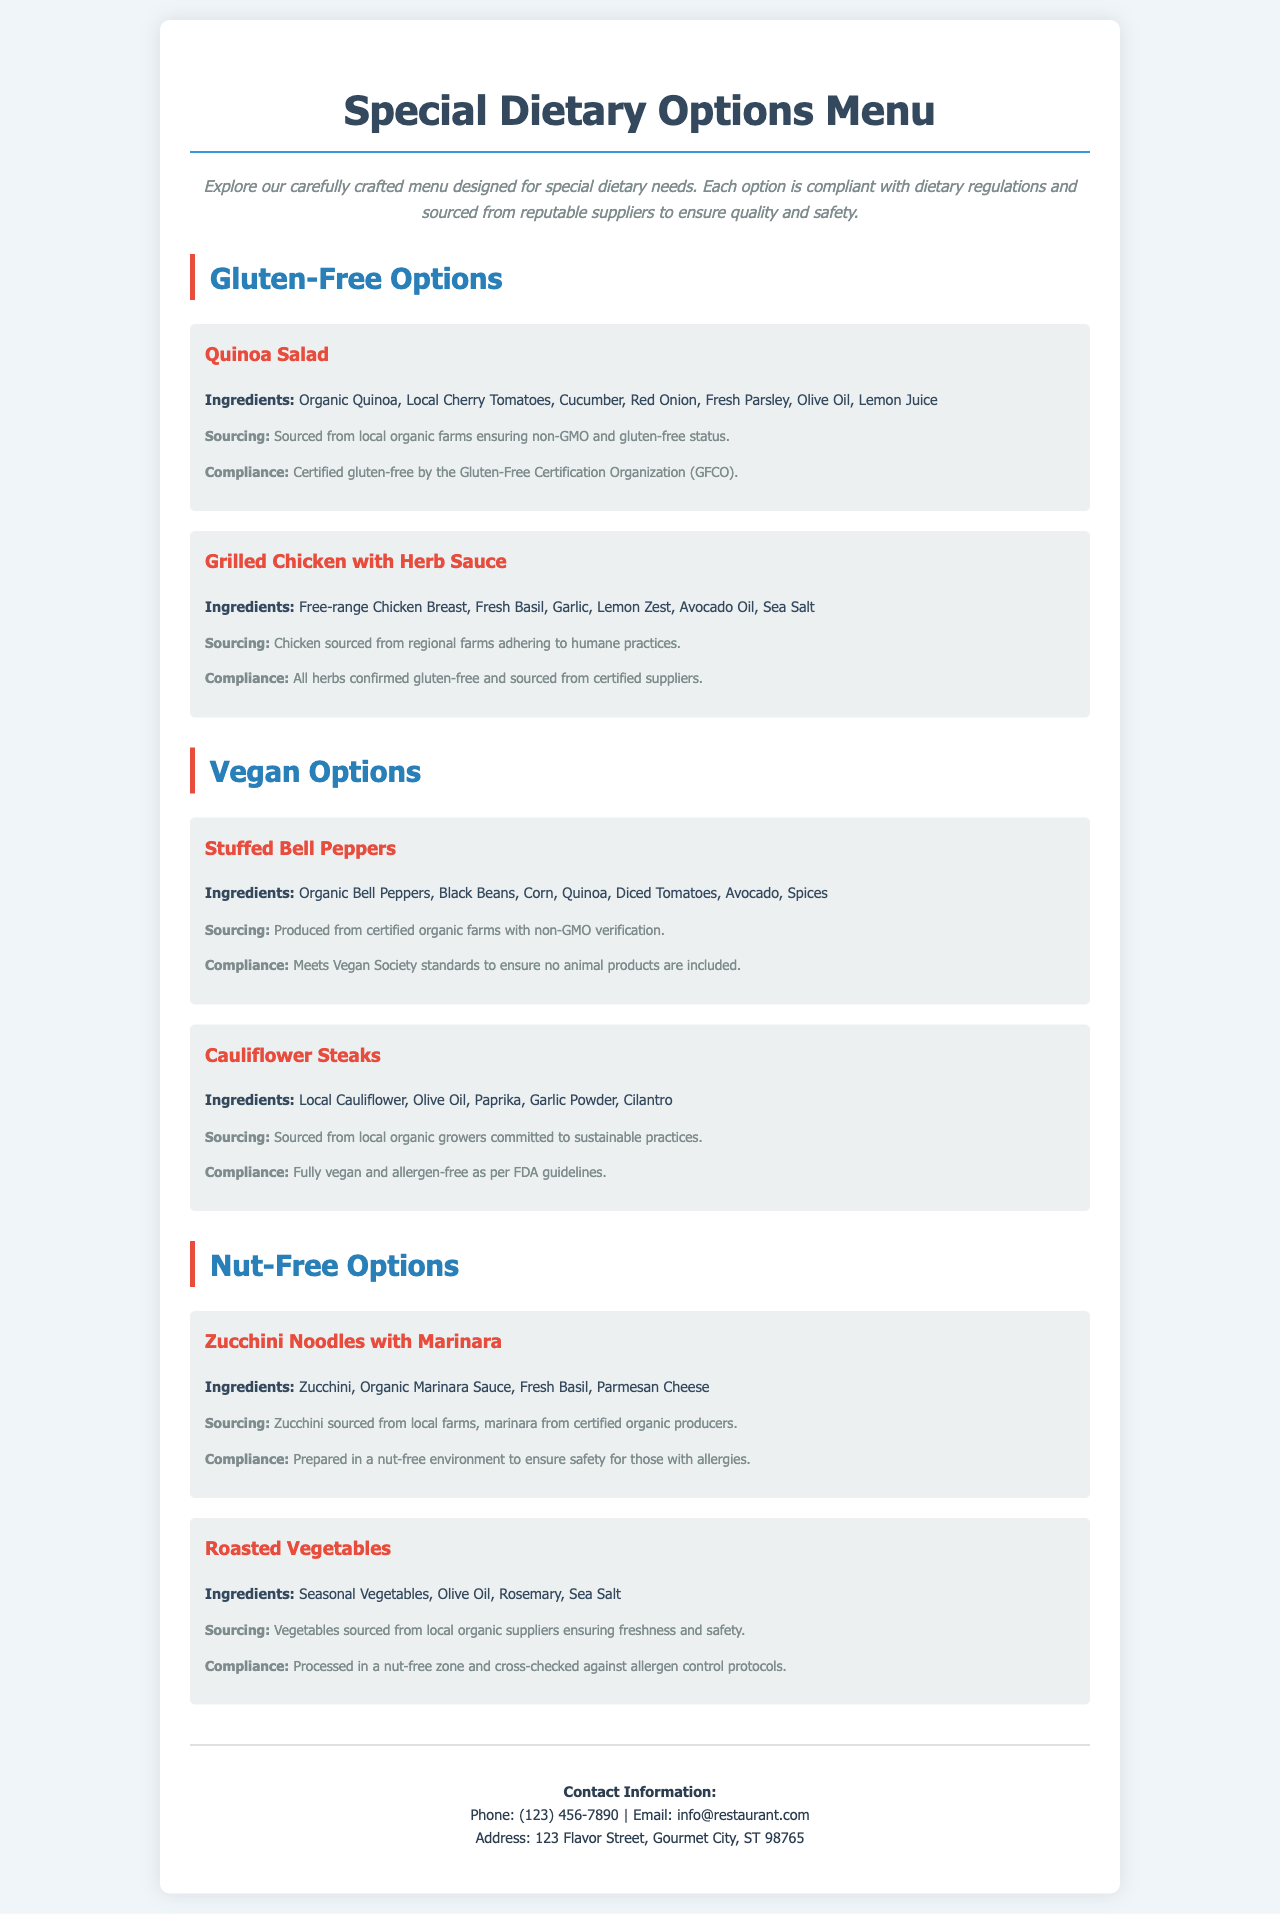What is the title of the menu? The title is prominently displayed at the top of the document, indicating the focus of the menu.
Answer: Special Dietary Options Menu How many gluten-free options are listed? The document lists gluten-free options in a specific section, which can be counted.
Answer: 2 What ingredient is common in both vegan options? By reviewing the ingredients listed under both vegan menu items, a common ingredient can be identified.
Answer: Quinoa What sourcing method is mentioned for the zucchini used in the nut-free option? The sourcing details provide insights into where the zucchinis are obtained and the type of farms.
Answer: Local farms Which certification is mentioned for the quinoa salad? The compliance section of the quinoa salad specifies a certification related to dietary regulations.
Answer: Certified gluten-free by the Gluten-Free Certification Organization Are the stuffed bell peppers allergen-free? Compliance details indicate the allergen status of the stuffed bell peppers, clarifying their safety for certain diets.
Answer: Yes What is the contact phone number for the restaurant? The contact information section includes details such as the phone number, which is easy to locate.
Answer: (123) 456-7890 What ingredient is used for the herb sauce in the grilled chicken dish? The ingredients for the grilled chicken dish list a specific item that is essential for the herb sauce.
Answer: Fresh Basil Which vegan option includes spice as an ingredient? Ingredients within the vegan options can be reviewed to identify those that include spices.
Answer: Stuffed Bell Peppers 